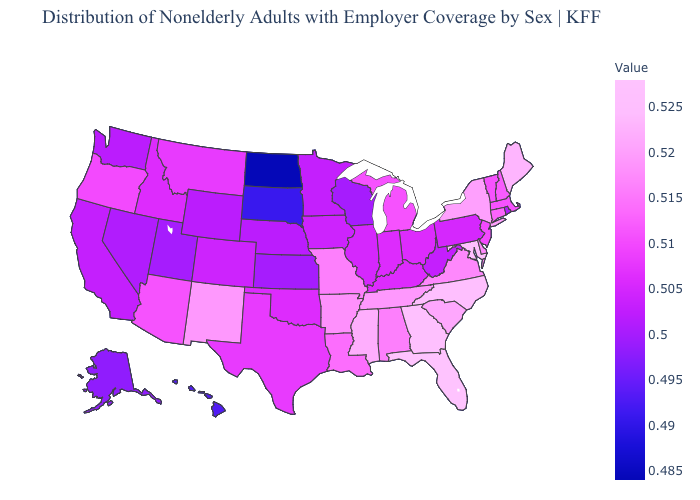Among the states that border Virginia , does Tennessee have the highest value?
Give a very brief answer. No. Does Illinois have the highest value in the MidWest?
Be succinct. No. Among the states that border Utah , does Wyoming have the lowest value?
Short answer required. No. 